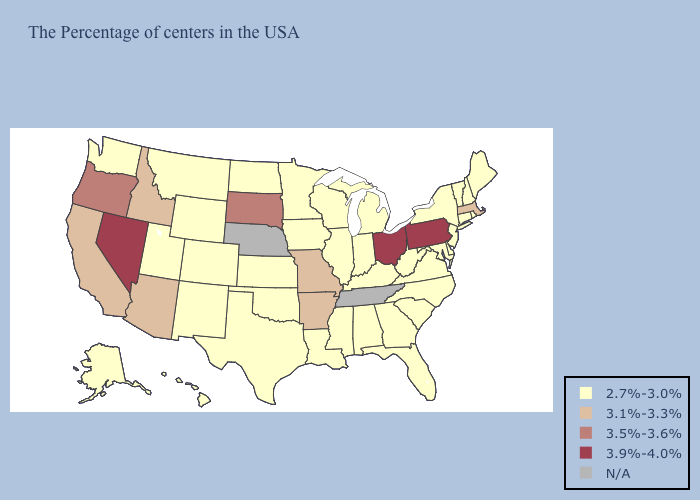Among the states that border Nebraska , does Wyoming have the highest value?
Short answer required. No. What is the lowest value in the USA?
Concise answer only. 2.7%-3.0%. What is the value of Colorado?
Concise answer only. 2.7%-3.0%. What is the lowest value in states that border Alabama?
Write a very short answer. 2.7%-3.0%. Name the states that have a value in the range N/A?
Concise answer only. Tennessee, Nebraska. What is the highest value in the USA?
Give a very brief answer. 3.9%-4.0%. What is the highest value in the USA?
Write a very short answer. 3.9%-4.0%. Which states have the lowest value in the USA?
Keep it brief. Maine, Rhode Island, New Hampshire, Vermont, Connecticut, New York, New Jersey, Delaware, Maryland, Virginia, North Carolina, South Carolina, West Virginia, Florida, Georgia, Michigan, Kentucky, Indiana, Alabama, Wisconsin, Illinois, Mississippi, Louisiana, Minnesota, Iowa, Kansas, Oklahoma, Texas, North Dakota, Wyoming, Colorado, New Mexico, Utah, Montana, Washington, Alaska, Hawaii. Name the states that have a value in the range 2.7%-3.0%?
Short answer required. Maine, Rhode Island, New Hampshire, Vermont, Connecticut, New York, New Jersey, Delaware, Maryland, Virginia, North Carolina, South Carolina, West Virginia, Florida, Georgia, Michigan, Kentucky, Indiana, Alabama, Wisconsin, Illinois, Mississippi, Louisiana, Minnesota, Iowa, Kansas, Oklahoma, Texas, North Dakota, Wyoming, Colorado, New Mexico, Utah, Montana, Washington, Alaska, Hawaii. What is the value of Maine?
Keep it brief. 2.7%-3.0%. Name the states that have a value in the range 3.1%-3.3%?
Write a very short answer. Massachusetts, Missouri, Arkansas, Arizona, Idaho, California. Does Massachusetts have the lowest value in the USA?
Answer briefly. No. Does Missouri have the lowest value in the MidWest?
Quick response, please. No. What is the highest value in states that border Pennsylvania?
Be succinct. 3.9%-4.0%. Among the states that border Indiana , does Michigan have the lowest value?
Keep it brief. Yes. 